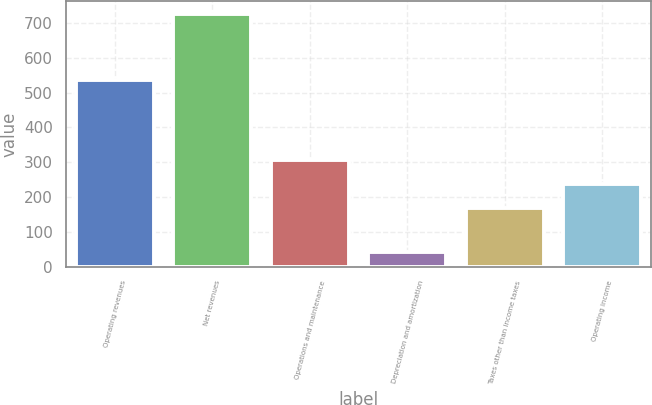Convert chart to OTSL. <chart><loc_0><loc_0><loc_500><loc_500><bar_chart><fcel>Operating revenues<fcel>Net revenues<fcel>Operations and maintenance<fcel>Depreciation and amortization<fcel>Taxes other than income taxes<fcel>Operating income<nl><fcel>537<fcel>726<fcel>307<fcel>43<fcel>170<fcel>238.3<nl></chart> 